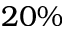Convert formula to latex. <formula><loc_0><loc_0><loc_500><loc_500>2 0 \%</formula> 